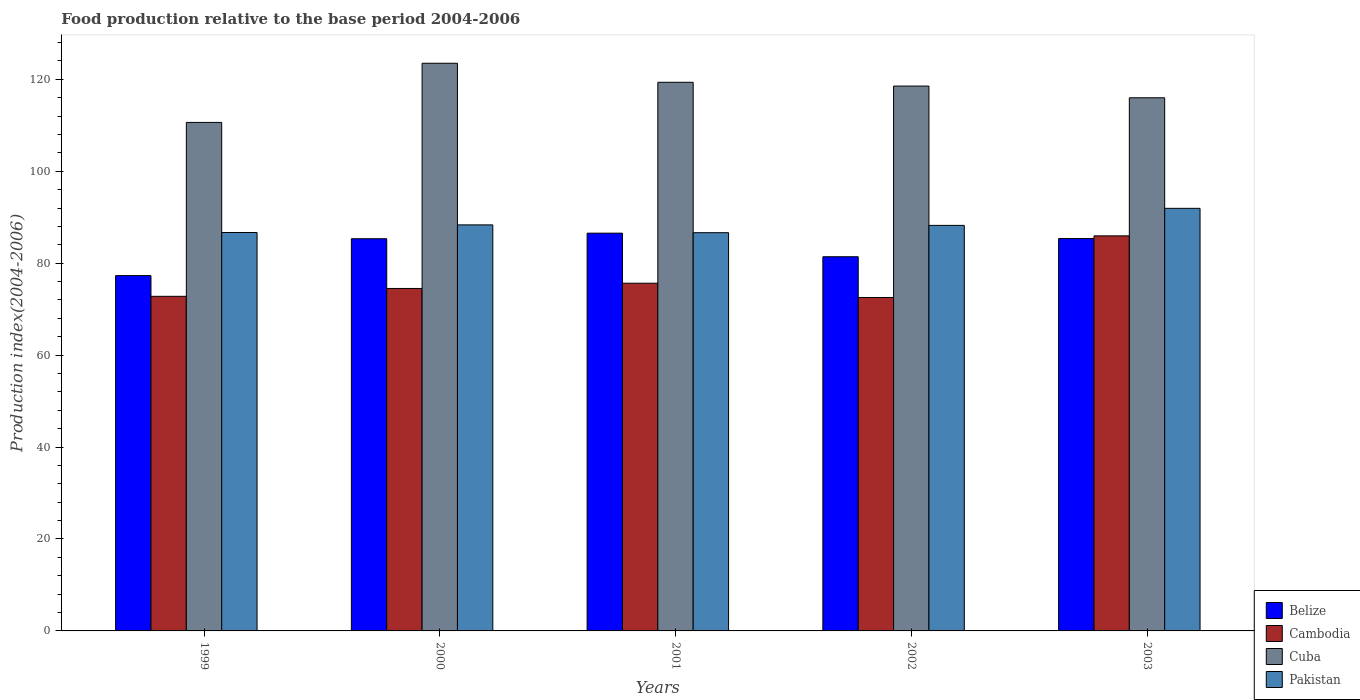How many different coloured bars are there?
Your answer should be compact. 4. How many groups of bars are there?
Ensure brevity in your answer.  5. Are the number of bars on each tick of the X-axis equal?
Provide a short and direct response. Yes. How many bars are there on the 3rd tick from the right?
Offer a terse response. 4. What is the food production index in Pakistan in 2000?
Provide a succinct answer. 88.33. Across all years, what is the maximum food production index in Cambodia?
Offer a terse response. 85.94. Across all years, what is the minimum food production index in Belize?
Give a very brief answer. 77.3. What is the total food production index in Cambodia in the graph?
Offer a terse response. 381.4. What is the difference between the food production index in Cuba in 2002 and that in 2003?
Keep it short and to the point. 2.55. What is the difference between the food production index in Pakistan in 2003 and the food production index in Belize in 2002?
Offer a terse response. 10.53. What is the average food production index in Cuba per year?
Provide a short and direct response. 117.59. In the year 2000, what is the difference between the food production index in Cuba and food production index in Cambodia?
Provide a succinct answer. 48.99. What is the ratio of the food production index in Pakistan in 2000 to that in 2002?
Your response must be concise. 1. What is the difference between the highest and the second highest food production index in Belize?
Your answer should be very brief. 1.17. What is the difference between the highest and the lowest food production index in Cambodia?
Offer a very short reply. 13.41. What does the 2nd bar from the left in 1999 represents?
Offer a very short reply. Cambodia. What does the 1st bar from the right in 2002 represents?
Your response must be concise. Pakistan. How many bars are there?
Provide a short and direct response. 20. Are all the bars in the graph horizontal?
Give a very brief answer. No. Are the values on the major ticks of Y-axis written in scientific E-notation?
Make the answer very short. No. Where does the legend appear in the graph?
Your response must be concise. Bottom right. How are the legend labels stacked?
Provide a short and direct response. Vertical. What is the title of the graph?
Your response must be concise. Food production relative to the base period 2004-2006. Does "Lower middle income" appear as one of the legend labels in the graph?
Ensure brevity in your answer.  No. What is the label or title of the Y-axis?
Keep it short and to the point. Production index(2004-2006). What is the Production index(2004-2006) of Belize in 1999?
Offer a very short reply. 77.3. What is the Production index(2004-2006) of Cambodia in 1999?
Keep it short and to the point. 72.79. What is the Production index(2004-2006) of Cuba in 1999?
Keep it short and to the point. 110.62. What is the Production index(2004-2006) in Pakistan in 1999?
Give a very brief answer. 86.67. What is the Production index(2004-2006) of Belize in 2000?
Your answer should be very brief. 85.32. What is the Production index(2004-2006) in Cambodia in 2000?
Make the answer very short. 74.5. What is the Production index(2004-2006) of Cuba in 2000?
Your answer should be very brief. 123.49. What is the Production index(2004-2006) of Pakistan in 2000?
Your answer should be compact. 88.33. What is the Production index(2004-2006) of Belize in 2001?
Offer a very short reply. 86.53. What is the Production index(2004-2006) of Cambodia in 2001?
Your response must be concise. 75.64. What is the Production index(2004-2006) in Cuba in 2001?
Provide a short and direct response. 119.35. What is the Production index(2004-2006) of Pakistan in 2001?
Provide a succinct answer. 86.63. What is the Production index(2004-2006) in Belize in 2002?
Provide a succinct answer. 81.4. What is the Production index(2004-2006) in Cambodia in 2002?
Offer a terse response. 72.53. What is the Production index(2004-2006) of Cuba in 2002?
Your answer should be compact. 118.53. What is the Production index(2004-2006) in Pakistan in 2002?
Your answer should be very brief. 88.22. What is the Production index(2004-2006) of Belize in 2003?
Give a very brief answer. 85.36. What is the Production index(2004-2006) of Cambodia in 2003?
Your answer should be compact. 85.94. What is the Production index(2004-2006) of Cuba in 2003?
Provide a succinct answer. 115.98. What is the Production index(2004-2006) of Pakistan in 2003?
Provide a short and direct response. 91.93. Across all years, what is the maximum Production index(2004-2006) of Belize?
Make the answer very short. 86.53. Across all years, what is the maximum Production index(2004-2006) of Cambodia?
Your response must be concise. 85.94. Across all years, what is the maximum Production index(2004-2006) in Cuba?
Ensure brevity in your answer.  123.49. Across all years, what is the maximum Production index(2004-2006) of Pakistan?
Ensure brevity in your answer.  91.93. Across all years, what is the minimum Production index(2004-2006) of Belize?
Make the answer very short. 77.3. Across all years, what is the minimum Production index(2004-2006) of Cambodia?
Make the answer very short. 72.53. Across all years, what is the minimum Production index(2004-2006) in Cuba?
Give a very brief answer. 110.62. Across all years, what is the minimum Production index(2004-2006) in Pakistan?
Make the answer very short. 86.63. What is the total Production index(2004-2006) in Belize in the graph?
Offer a very short reply. 415.91. What is the total Production index(2004-2006) of Cambodia in the graph?
Offer a very short reply. 381.4. What is the total Production index(2004-2006) in Cuba in the graph?
Your answer should be compact. 587.97. What is the total Production index(2004-2006) of Pakistan in the graph?
Your answer should be very brief. 441.78. What is the difference between the Production index(2004-2006) of Belize in 1999 and that in 2000?
Offer a terse response. -8.02. What is the difference between the Production index(2004-2006) of Cambodia in 1999 and that in 2000?
Ensure brevity in your answer.  -1.71. What is the difference between the Production index(2004-2006) in Cuba in 1999 and that in 2000?
Your answer should be very brief. -12.87. What is the difference between the Production index(2004-2006) in Pakistan in 1999 and that in 2000?
Offer a very short reply. -1.66. What is the difference between the Production index(2004-2006) of Belize in 1999 and that in 2001?
Your response must be concise. -9.23. What is the difference between the Production index(2004-2006) of Cambodia in 1999 and that in 2001?
Your answer should be compact. -2.85. What is the difference between the Production index(2004-2006) in Cuba in 1999 and that in 2001?
Your answer should be compact. -8.73. What is the difference between the Production index(2004-2006) of Cambodia in 1999 and that in 2002?
Your response must be concise. 0.26. What is the difference between the Production index(2004-2006) of Cuba in 1999 and that in 2002?
Make the answer very short. -7.91. What is the difference between the Production index(2004-2006) of Pakistan in 1999 and that in 2002?
Provide a succinct answer. -1.55. What is the difference between the Production index(2004-2006) in Belize in 1999 and that in 2003?
Provide a short and direct response. -8.06. What is the difference between the Production index(2004-2006) in Cambodia in 1999 and that in 2003?
Make the answer very short. -13.15. What is the difference between the Production index(2004-2006) of Cuba in 1999 and that in 2003?
Offer a very short reply. -5.36. What is the difference between the Production index(2004-2006) of Pakistan in 1999 and that in 2003?
Provide a succinct answer. -5.26. What is the difference between the Production index(2004-2006) of Belize in 2000 and that in 2001?
Your answer should be very brief. -1.21. What is the difference between the Production index(2004-2006) in Cambodia in 2000 and that in 2001?
Offer a very short reply. -1.14. What is the difference between the Production index(2004-2006) in Cuba in 2000 and that in 2001?
Provide a succinct answer. 4.14. What is the difference between the Production index(2004-2006) of Pakistan in 2000 and that in 2001?
Give a very brief answer. 1.7. What is the difference between the Production index(2004-2006) of Belize in 2000 and that in 2002?
Provide a succinct answer. 3.92. What is the difference between the Production index(2004-2006) of Cambodia in 2000 and that in 2002?
Your answer should be compact. 1.97. What is the difference between the Production index(2004-2006) in Cuba in 2000 and that in 2002?
Your answer should be compact. 4.96. What is the difference between the Production index(2004-2006) in Pakistan in 2000 and that in 2002?
Give a very brief answer. 0.11. What is the difference between the Production index(2004-2006) in Belize in 2000 and that in 2003?
Make the answer very short. -0.04. What is the difference between the Production index(2004-2006) of Cambodia in 2000 and that in 2003?
Ensure brevity in your answer.  -11.44. What is the difference between the Production index(2004-2006) of Cuba in 2000 and that in 2003?
Provide a succinct answer. 7.51. What is the difference between the Production index(2004-2006) of Belize in 2001 and that in 2002?
Provide a short and direct response. 5.13. What is the difference between the Production index(2004-2006) in Cambodia in 2001 and that in 2002?
Give a very brief answer. 3.11. What is the difference between the Production index(2004-2006) in Cuba in 2001 and that in 2002?
Provide a succinct answer. 0.82. What is the difference between the Production index(2004-2006) of Pakistan in 2001 and that in 2002?
Your response must be concise. -1.59. What is the difference between the Production index(2004-2006) in Belize in 2001 and that in 2003?
Offer a terse response. 1.17. What is the difference between the Production index(2004-2006) in Cambodia in 2001 and that in 2003?
Provide a succinct answer. -10.3. What is the difference between the Production index(2004-2006) in Cuba in 2001 and that in 2003?
Provide a short and direct response. 3.37. What is the difference between the Production index(2004-2006) in Pakistan in 2001 and that in 2003?
Provide a succinct answer. -5.3. What is the difference between the Production index(2004-2006) of Belize in 2002 and that in 2003?
Offer a very short reply. -3.96. What is the difference between the Production index(2004-2006) in Cambodia in 2002 and that in 2003?
Provide a succinct answer. -13.41. What is the difference between the Production index(2004-2006) of Cuba in 2002 and that in 2003?
Your answer should be very brief. 2.55. What is the difference between the Production index(2004-2006) of Pakistan in 2002 and that in 2003?
Provide a succinct answer. -3.71. What is the difference between the Production index(2004-2006) of Belize in 1999 and the Production index(2004-2006) of Cuba in 2000?
Keep it short and to the point. -46.19. What is the difference between the Production index(2004-2006) of Belize in 1999 and the Production index(2004-2006) of Pakistan in 2000?
Your answer should be very brief. -11.03. What is the difference between the Production index(2004-2006) of Cambodia in 1999 and the Production index(2004-2006) of Cuba in 2000?
Provide a succinct answer. -50.7. What is the difference between the Production index(2004-2006) in Cambodia in 1999 and the Production index(2004-2006) in Pakistan in 2000?
Keep it short and to the point. -15.54. What is the difference between the Production index(2004-2006) in Cuba in 1999 and the Production index(2004-2006) in Pakistan in 2000?
Provide a short and direct response. 22.29. What is the difference between the Production index(2004-2006) in Belize in 1999 and the Production index(2004-2006) in Cambodia in 2001?
Your answer should be very brief. 1.66. What is the difference between the Production index(2004-2006) in Belize in 1999 and the Production index(2004-2006) in Cuba in 2001?
Offer a very short reply. -42.05. What is the difference between the Production index(2004-2006) in Belize in 1999 and the Production index(2004-2006) in Pakistan in 2001?
Your answer should be very brief. -9.33. What is the difference between the Production index(2004-2006) in Cambodia in 1999 and the Production index(2004-2006) in Cuba in 2001?
Keep it short and to the point. -46.56. What is the difference between the Production index(2004-2006) of Cambodia in 1999 and the Production index(2004-2006) of Pakistan in 2001?
Keep it short and to the point. -13.84. What is the difference between the Production index(2004-2006) of Cuba in 1999 and the Production index(2004-2006) of Pakistan in 2001?
Provide a short and direct response. 23.99. What is the difference between the Production index(2004-2006) in Belize in 1999 and the Production index(2004-2006) in Cambodia in 2002?
Give a very brief answer. 4.77. What is the difference between the Production index(2004-2006) in Belize in 1999 and the Production index(2004-2006) in Cuba in 2002?
Give a very brief answer. -41.23. What is the difference between the Production index(2004-2006) in Belize in 1999 and the Production index(2004-2006) in Pakistan in 2002?
Your answer should be very brief. -10.92. What is the difference between the Production index(2004-2006) of Cambodia in 1999 and the Production index(2004-2006) of Cuba in 2002?
Provide a succinct answer. -45.74. What is the difference between the Production index(2004-2006) in Cambodia in 1999 and the Production index(2004-2006) in Pakistan in 2002?
Give a very brief answer. -15.43. What is the difference between the Production index(2004-2006) of Cuba in 1999 and the Production index(2004-2006) of Pakistan in 2002?
Keep it short and to the point. 22.4. What is the difference between the Production index(2004-2006) in Belize in 1999 and the Production index(2004-2006) in Cambodia in 2003?
Offer a very short reply. -8.64. What is the difference between the Production index(2004-2006) of Belize in 1999 and the Production index(2004-2006) of Cuba in 2003?
Offer a very short reply. -38.68. What is the difference between the Production index(2004-2006) in Belize in 1999 and the Production index(2004-2006) in Pakistan in 2003?
Offer a very short reply. -14.63. What is the difference between the Production index(2004-2006) in Cambodia in 1999 and the Production index(2004-2006) in Cuba in 2003?
Provide a succinct answer. -43.19. What is the difference between the Production index(2004-2006) of Cambodia in 1999 and the Production index(2004-2006) of Pakistan in 2003?
Your response must be concise. -19.14. What is the difference between the Production index(2004-2006) of Cuba in 1999 and the Production index(2004-2006) of Pakistan in 2003?
Your answer should be very brief. 18.69. What is the difference between the Production index(2004-2006) of Belize in 2000 and the Production index(2004-2006) of Cambodia in 2001?
Keep it short and to the point. 9.68. What is the difference between the Production index(2004-2006) in Belize in 2000 and the Production index(2004-2006) in Cuba in 2001?
Offer a terse response. -34.03. What is the difference between the Production index(2004-2006) of Belize in 2000 and the Production index(2004-2006) of Pakistan in 2001?
Your answer should be compact. -1.31. What is the difference between the Production index(2004-2006) in Cambodia in 2000 and the Production index(2004-2006) in Cuba in 2001?
Give a very brief answer. -44.85. What is the difference between the Production index(2004-2006) of Cambodia in 2000 and the Production index(2004-2006) of Pakistan in 2001?
Your response must be concise. -12.13. What is the difference between the Production index(2004-2006) in Cuba in 2000 and the Production index(2004-2006) in Pakistan in 2001?
Offer a terse response. 36.86. What is the difference between the Production index(2004-2006) of Belize in 2000 and the Production index(2004-2006) of Cambodia in 2002?
Your answer should be very brief. 12.79. What is the difference between the Production index(2004-2006) in Belize in 2000 and the Production index(2004-2006) in Cuba in 2002?
Keep it short and to the point. -33.21. What is the difference between the Production index(2004-2006) of Belize in 2000 and the Production index(2004-2006) of Pakistan in 2002?
Give a very brief answer. -2.9. What is the difference between the Production index(2004-2006) of Cambodia in 2000 and the Production index(2004-2006) of Cuba in 2002?
Provide a short and direct response. -44.03. What is the difference between the Production index(2004-2006) of Cambodia in 2000 and the Production index(2004-2006) of Pakistan in 2002?
Ensure brevity in your answer.  -13.72. What is the difference between the Production index(2004-2006) in Cuba in 2000 and the Production index(2004-2006) in Pakistan in 2002?
Your response must be concise. 35.27. What is the difference between the Production index(2004-2006) of Belize in 2000 and the Production index(2004-2006) of Cambodia in 2003?
Your answer should be very brief. -0.62. What is the difference between the Production index(2004-2006) in Belize in 2000 and the Production index(2004-2006) in Cuba in 2003?
Your answer should be compact. -30.66. What is the difference between the Production index(2004-2006) of Belize in 2000 and the Production index(2004-2006) of Pakistan in 2003?
Offer a terse response. -6.61. What is the difference between the Production index(2004-2006) of Cambodia in 2000 and the Production index(2004-2006) of Cuba in 2003?
Ensure brevity in your answer.  -41.48. What is the difference between the Production index(2004-2006) in Cambodia in 2000 and the Production index(2004-2006) in Pakistan in 2003?
Ensure brevity in your answer.  -17.43. What is the difference between the Production index(2004-2006) in Cuba in 2000 and the Production index(2004-2006) in Pakistan in 2003?
Make the answer very short. 31.56. What is the difference between the Production index(2004-2006) of Belize in 2001 and the Production index(2004-2006) of Cambodia in 2002?
Offer a terse response. 14. What is the difference between the Production index(2004-2006) of Belize in 2001 and the Production index(2004-2006) of Cuba in 2002?
Offer a very short reply. -32. What is the difference between the Production index(2004-2006) of Belize in 2001 and the Production index(2004-2006) of Pakistan in 2002?
Your response must be concise. -1.69. What is the difference between the Production index(2004-2006) in Cambodia in 2001 and the Production index(2004-2006) in Cuba in 2002?
Provide a short and direct response. -42.89. What is the difference between the Production index(2004-2006) in Cambodia in 2001 and the Production index(2004-2006) in Pakistan in 2002?
Your response must be concise. -12.58. What is the difference between the Production index(2004-2006) in Cuba in 2001 and the Production index(2004-2006) in Pakistan in 2002?
Make the answer very short. 31.13. What is the difference between the Production index(2004-2006) of Belize in 2001 and the Production index(2004-2006) of Cambodia in 2003?
Your response must be concise. 0.59. What is the difference between the Production index(2004-2006) in Belize in 2001 and the Production index(2004-2006) in Cuba in 2003?
Make the answer very short. -29.45. What is the difference between the Production index(2004-2006) of Cambodia in 2001 and the Production index(2004-2006) of Cuba in 2003?
Offer a very short reply. -40.34. What is the difference between the Production index(2004-2006) of Cambodia in 2001 and the Production index(2004-2006) of Pakistan in 2003?
Provide a short and direct response. -16.29. What is the difference between the Production index(2004-2006) in Cuba in 2001 and the Production index(2004-2006) in Pakistan in 2003?
Offer a terse response. 27.42. What is the difference between the Production index(2004-2006) in Belize in 2002 and the Production index(2004-2006) in Cambodia in 2003?
Your response must be concise. -4.54. What is the difference between the Production index(2004-2006) of Belize in 2002 and the Production index(2004-2006) of Cuba in 2003?
Ensure brevity in your answer.  -34.58. What is the difference between the Production index(2004-2006) in Belize in 2002 and the Production index(2004-2006) in Pakistan in 2003?
Ensure brevity in your answer.  -10.53. What is the difference between the Production index(2004-2006) in Cambodia in 2002 and the Production index(2004-2006) in Cuba in 2003?
Keep it short and to the point. -43.45. What is the difference between the Production index(2004-2006) of Cambodia in 2002 and the Production index(2004-2006) of Pakistan in 2003?
Keep it short and to the point. -19.4. What is the difference between the Production index(2004-2006) in Cuba in 2002 and the Production index(2004-2006) in Pakistan in 2003?
Provide a succinct answer. 26.6. What is the average Production index(2004-2006) in Belize per year?
Keep it short and to the point. 83.18. What is the average Production index(2004-2006) of Cambodia per year?
Your answer should be very brief. 76.28. What is the average Production index(2004-2006) in Cuba per year?
Offer a very short reply. 117.59. What is the average Production index(2004-2006) in Pakistan per year?
Provide a succinct answer. 88.36. In the year 1999, what is the difference between the Production index(2004-2006) of Belize and Production index(2004-2006) of Cambodia?
Offer a terse response. 4.51. In the year 1999, what is the difference between the Production index(2004-2006) in Belize and Production index(2004-2006) in Cuba?
Your response must be concise. -33.32. In the year 1999, what is the difference between the Production index(2004-2006) in Belize and Production index(2004-2006) in Pakistan?
Your answer should be very brief. -9.37. In the year 1999, what is the difference between the Production index(2004-2006) in Cambodia and Production index(2004-2006) in Cuba?
Offer a very short reply. -37.83. In the year 1999, what is the difference between the Production index(2004-2006) in Cambodia and Production index(2004-2006) in Pakistan?
Offer a very short reply. -13.88. In the year 1999, what is the difference between the Production index(2004-2006) of Cuba and Production index(2004-2006) of Pakistan?
Make the answer very short. 23.95. In the year 2000, what is the difference between the Production index(2004-2006) of Belize and Production index(2004-2006) of Cambodia?
Your answer should be very brief. 10.82. In the year 2000, what is the difference between the Production index(2004-2006) of Belize and Production index(2004-2006) of Cuba?
Make the answer very short. -38.17. In the year 2000, what is the difference between the Production index(2004-2006) in Belize and Production index(2004-2006) in Pakistan?
Keep it short and to the point. -3.01. In the year 2000, what is the difference between the Production index(2004-2006) of Cambodia and Production index(2004-2006) of Cuba?
Keep it short and to the point. -48.99. In the year 2000, what is the difference between the Production index(2004-2006) in Cambodia and Production index(2004-2006) in Pakistan?
Provide a succinct answer. -13.83. In the year 2000, what is the difference between the Production index(2004-2006) in Cuba and Production index(2004-2006) in Pakistan?
Provide a succinct answer. 35.16. In the year 2001, what is the difference between the Production index(2004-2006) of Belize and Production index(2004-2006) of Cambodia?
Offer a very short reply. 10.89. In the year 2001, what is the difference between the Production index(2004-2006) of Belize and Production index(2004-2006) of Cuba?
Ensure brevity in your answer.  -32.82. In the year 2001, what is the difference between the Production index(2004-2006) in Cambodia and Production index(2004-2006) in Cuba?
Make the answer very short. -43.71. In the year 2001, what is the difference between the Production index(2004-2006) of Cambodia and Production index(2004-2006) of Pakistan?
Ensure brevity in your answer.  -10.99. In the year 2001, what is the difference between the Production index(2004-2006) in Cuba and Production index(2004-2006) in Pakistan?
Your response must be concise. 32.72. In the year 2002, what is the difference between the Production index(2004-2006) in Belize and Production index(2004-2006) in Cambodia?
Your answer should be very brief. 8.87. In the year 2002, what is the difference between the Production index(2004-2006) of Belize and Production index(2004-2006) of Cuba?
Provide a succinct answer. -37.13. In the year 2002, what is the difference between the Production index(2004-2006) of Belize and Production index(2004-2006) of Pakistan?
Keep it short and to the point. -6.82. In the year 2002, what is the difference between the Production index(2004-2006) in Cambodia and Production index(2004-2006) in Cuba?
Provide a succinct answer. -46. In the year 2002, what is the difference between the Production index(2004-2006) in Cambodia and Production index(2004-2006) in Pakistan?
Ensure brevity in your answer.  -15.69. In the year 2002, what is the difference between the Production index(2004-2006) in Cuba and Production index(2004-2006) in Pakistan?
Keep it short and to the point. 30.31. In the year 2003, what is the difference between the Production index(2004-2006) in Belize and Production index(2004-2006) in Cambodia?
Your answer should be very brief. -0.58. In the year 2003, what is the difference between the Production index(2004-2006) in Belize and Production index(2004-2006) in Cuba?
Offer a very short reply. -30.62. In the year 2003, what is the difference between the Production index(2004-2006) of Belize and Production index(2004-2006) of Pakistan?
Make the answer very short. -6.57. In the year 2003, what is the difference between the Production index(2004-2006) of Cambodia and Production index(2004-2006) of Cuba?
Provide a short and direct response. -30.04. In the year 2003, what is the difference between the Production index(2004-2006) of Cambodia and Production index(2004-2006) of Pakistan?
Give a very brief answer. -5.99. In the year 2003, what is the difference between the Production index(2004-2006) in Cuba and Production index(2004-2006) in Pakistan?
Your response must be concise. 24.05. What is the ratio of the Production index(2004-2006) in Belize in 1999 to that in 2000?
Your answer should be very brief. 0.91. What is the ratio of the Production index(2004-2006) in Cambodia in 1999 to that in 2000?
Your answer should be compact. 0.98. What is the ratio of the Production index(2004-2006) of Cuba in 1999 to that in 2000?
Offer a very short reply. 0.9. What is the ratio of the Production index(2004-2006) of Pakistan in 1999 to that in 2000?
Your answer should be compact. 0.98. What is the ratio of the Production index(2004-2006) in Belize in 1999 to that in 2001?
Provide a short and direct response. 0.89. What is the ratio of the Production index(2004-2006) of Cambodia in 1999 to that in 2001?
Keep it short and to the point. 0.96. What is the ratio of the Production index(2004-2006) in Cuba in 1999 to that in 2001?
Your response must be concise. 0.93. What is the ratio of the Production index(2004-2006) in Belize in 1999 to that in 2002?
Provide a succinct answer. 0.95. What is the ratio of the Production index(2004-2006) of Cambodia in 1999 to that in 2002?
Your answer should be very brief. 1. What is the ratio of the Production index(2004-2006) in Cuba in 1999 to that in 2002?
Your response must be concise. 0.93. What is the ratio of the Production index(2004-2006) in Pakistan in 1999 to that in 2002?
Provide a short and direct response. 0.98. What is the ratio of the Production index(2004-2006) in Belize in 1999 to that in 2003?
Make the answer very short. 0.91. What is the ratio of the Production index(2004-2006) in Cambodia in 1999 to that in 2003?
Your answer should be compact. 0.85. What is the ratio of the Production index(2004-2006) in Cuba in 1999 to that in 2003?
Offer a very short reply. 0.95. What is the ratio of the Production index(2004-2006) of Pakistan in 1999 to that in 2003?
Offer a very short reply. 0.94. What is the ratio of the Production index(2004-2006) of Belize in 2000 to that in 2001?
Make the answer very short. 0.99. What is the ratio of the Production index(2004-2006) in Cambodia in 2000 to that in 2001?
Make the answer very short. 0.98. What is the ratio of the Production index(2004-2006) of Cuba in 2000 to that in 2001?
Give a very brief answer. 1.03. What is the ratio of the Production index(2004-2006) of Pakistan in 2000 to that in 2001?
Your answer should be compact. 1.02. What is the ratio of the Production index(2004-2006) of Belize in 2000 to that in 2002?
Make the answer very short. 1.05. What is the ratio of the Production index(2004-2006) in Cambodia in 2000 to that in 2002?
Make the answer very short. 1.03. What is the ratio of the Production index(2004-2006) of Cuba in 2000 to that in 2002?
Offer a terse response. 1.04. What is the ratio of the Production index(2004-2006) in Pakistan in 2000 to that in 2002?
Offer a very short reply. 1. What is the ratio of the Production index(2004-2006) of Belize in 2000 to that in 2003?
Offer a very short reply. 1. What is the ratio of the Production index(2004-2006) of Cambodia in 2000 to that in 2003?
Offer a very short reply. 0.87. What is the ratio of the Production index(2004-2006) of Cuba in 2000 to that in 2003?
Your answer should be compact. 1.06. What is the ratio of the Production index(2004-2006) of Pakistan in 2000 to that in 2003?
Offer a terse response. 0.96. What is the ratio of the Production index(2004-2006) in Belize in 2001 to that in 2002?
Provide a short and direct response. 1.06. What is the ratio of the Production index(2004-2006) of Cambodia in 2001 to that in 2002?
Ensure brevity in your answer.  1.04. What is the ratio of the Production index(2004-2006) of Cuba in 2001 to that in 2002?
Your response must be concise. 1.01. What is the ratio of the Production index(2004-2006) in Belize in 2001 to that in 2003?
Provide a succinct answer. 1.01. What is the ratio of the Production index(2004-2006) in Cambodia in 2001 to that in 2003?
Your response must be concise. 0.88. What is the ratio of the Production index(2004-2006) of Cuba in 2001 to that in 2003?
Ensure brevity in your answer.  1.03. What is the ratio of the Production index(2004-2006) of Pakistan in 2001 to that in 2003?
Offer a very short reply. 0.94. What is the ratio of the Production index(2004-2006) of Belize in 2002 to that in 2003?
Your answer should be very brief. 0.95. What is the ratio of the Production index(2004-2006) of Cambodia in 2002 to that in 2003?
Make the answer very short. 0.84. What is the ratio of the Production index(2004-2006) of Pakistan in 2002 to that in 2003?
Provide a succinct answer. 0.96. What is the difference between the highest and the second highest Production index(2004-2006) of Belize?
Offer a very short reply. 1.17. What is the difference between the highest and the second highest Production index(2004-2006) in Cuba?
Keep it short and to the point. 4.14. What is the difference between the highest and the second highest Production index(2004-2006) of Pakistan?
Provide a succinct answer. 3.6. What is the difference between the highest and the lowest Production index(2004-2006) of Belize?
Provide a short and direct response. 9.23. What is the difference between the highest and the lowest Production index(2004-2006) in Cambodia?
Give a very brief answer. 13.41. What is the difference between the highest and the lowest Production index(2004-2006) in Cuba?
Your response must be concise. 12.87. What is the difference between the highest and the lowest Production index(2004-2006) of Pakistan?
Give a very brief answer. 5.3. 